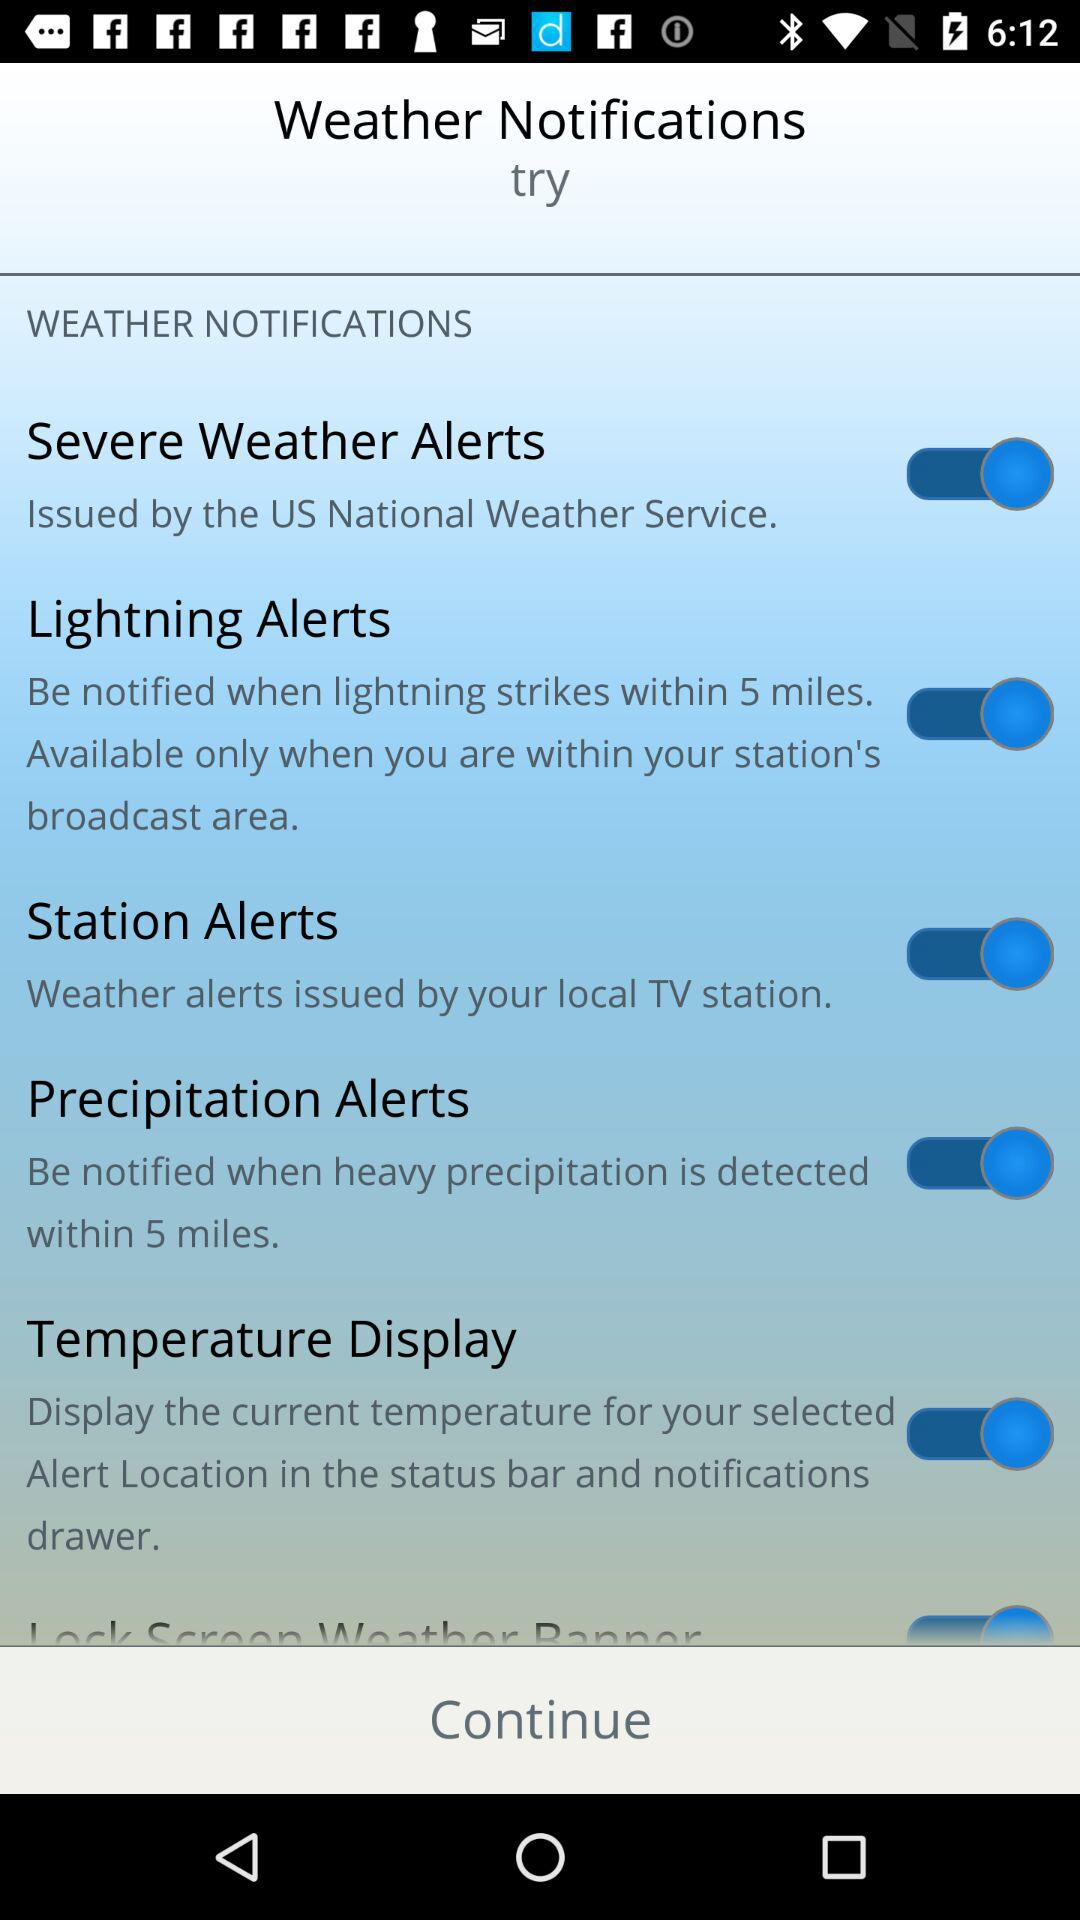What is the status of "Station Alerts"? The status is "on". 